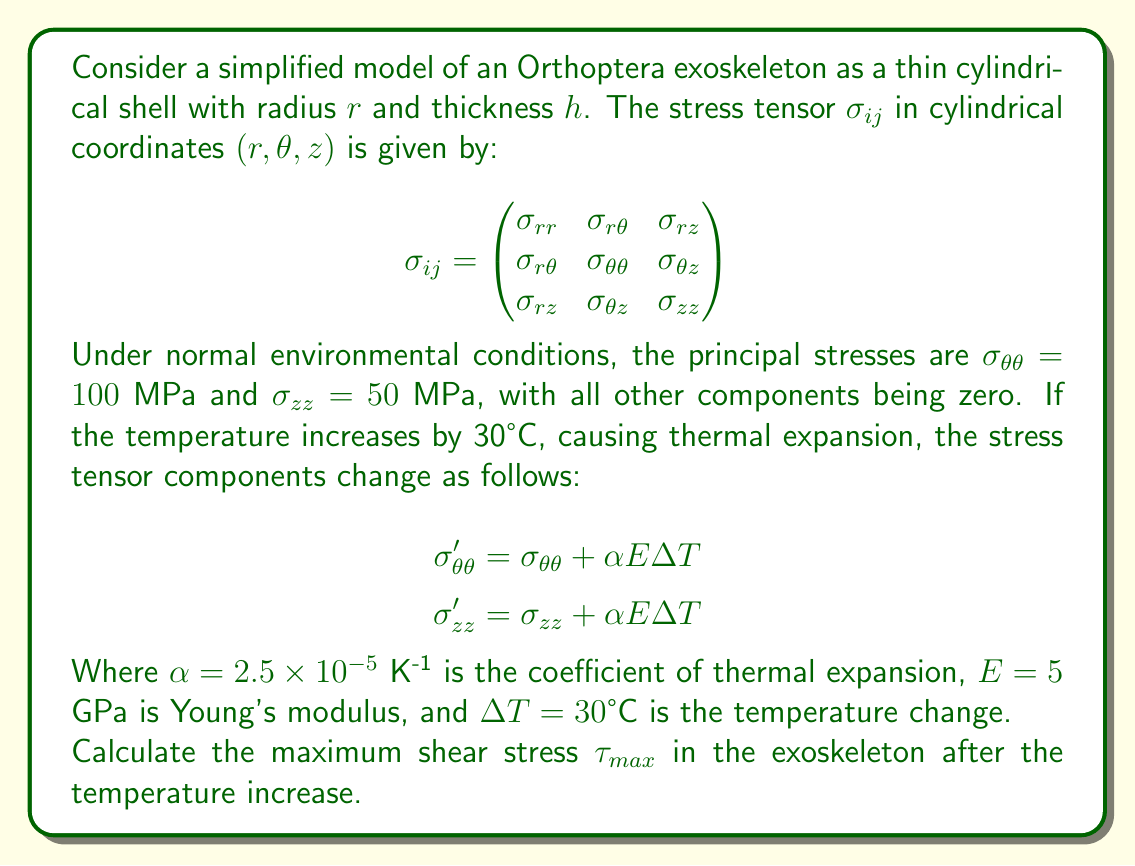Teach me how to tackle this problem. To solve this problem, we'll follow these steps:

1) First, let's calculate the new stress tensor components after the temperature increase:

   $$\sigma_{\theta\theta}' = 100 + (2.5 \times 10^{-5})(5 \times 10^9)(30) = 103.75 \text{ MPa}$$
   $$\sigma_{zz}' = 50 + (2.5 \times 10^{-5})(5 \times 10^9)(30) = 53.75 \text{ MPa}$$

2) Now, our stress tensor looks like this:

   $$\sigma_{ij}' = \begin{pmatrix}
   0 & 0 & 0 \\
   0 & 103.75 & 0 \\
   0 & 0 & 53.75
   \end{pmatrix}$$

3) To find the maximum shear stress, we need to use the principal stresses. In this case, the principal stresses are already given by the diagonal elements of our stress tensor:

   $$\sigma_1 = 103.75 \text{ MPa}$$
   $$\sigma_2 = 53.75 \text{ MPa}$$
   $$\sigma_3 = 0 \text{ MPa}$$

4) The maximum shear stress is given by the formula:

   $$\tau_{max} = \frac{\sigma_{max} - \sigma_{min}}{2}$$

   Where $\sigma_{max}$ is the largest principal stress and $\sigma_{min}$ is the smallest principal stress.

5) Substituting our values:

   $$\tau_{max} = \frac{103.75 - 0}{2} = 51.875 \text{ MPa}$$

Therefore, the maximum shear stress in the exoskeleton after the temperature increase is 51.875 MPa.
Answer: 51.875 MPa 